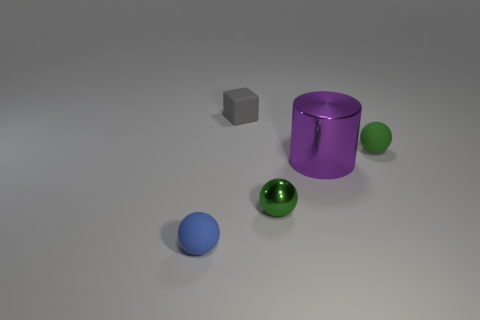Add 4 blue spheres. How many objects exist? 9 Subtract all balls. How many objects are left? 2 Subtract all purple objects. Subtract all metallic things. How many objects are left? 2 Add 2 blocks. How many blocks are left? 3 Add 3 yellow shiny cubes. How many yellow shiny cubes exist? 3 Subtract 2 green balls. How many objects are left? 3 